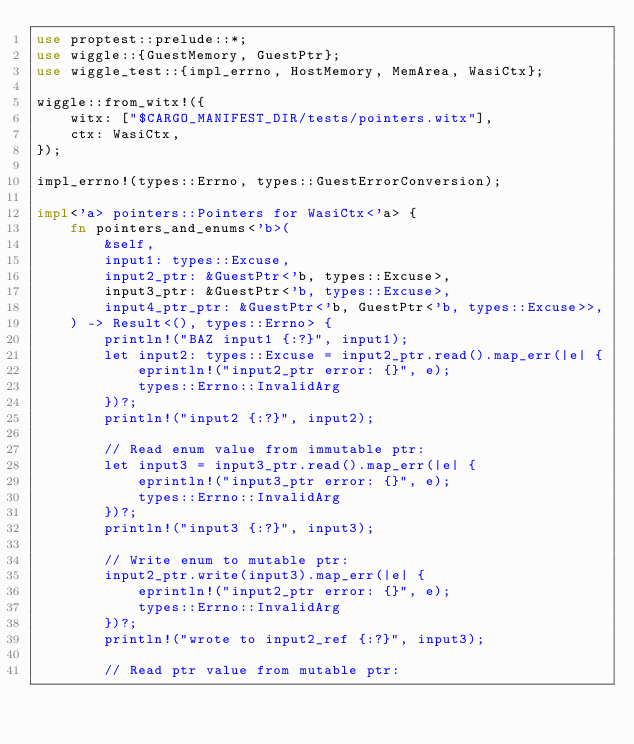<code> <loc_0><loc_0><loc_500><loc_500><_Rust_>use proptest::prelude::*;
use wiggle::{GuestMemory, GuestPtr};
use wiggle_test::{impl_errno, HostMemory, MemArea, WasiCtx};

wiggle::from_witx!({
    witx: ["$CARGO_MANIFEST_DIR/tests/pointers.witx"],
    ctx: WasiCtx,
});

impl_errno!(types::Errno, types::GuestErrorConversion);

impl<'a> pointers::Pointers for WasiCtx<'a> {
    fn pointers_and_enums<'b>(
        &self,
        input1: types::Excuse,
        input2_ptr: &GuestPtr<'b, types::Excuse>,
        input3_ptr: &GuestPtr<'b, types::Excuse>,
        input4_ptr_ptr: &GuestPtr<'b, GuestPtr<'b, types::Excuse>>,
    ) -> Result<(), types::Errno> {
        println!("BAZ input1 {:?}", input1);
        let input2: types::Excuse = input2_ptr.read().map_err(|e| {
            eprintln!("input2_ptr error: {}", e);
            types::Errno::InvalidArg
        })?;
        println!("input2 {:?}", input2);

        // Read enum value from immutable ptr:
        let input3 = input3_ptr.read().map_err(|e| {
            eprintln!("input3_ptr error: {}", e);
            types::Errno::InvalidArg
        })?;
        println!("input3 {:?}", input3);

        // Write enum to mutable ptr:
        input2_ptr.write(input3).map_err(|e| {
            eprintln!("input2_ptr error: {}", e);
            types::Errno::InvalidArg
        })?;
        println!("wrote to input2_ref {:?}", input3);

        // Read ptr value from mutable ptr:</code> 